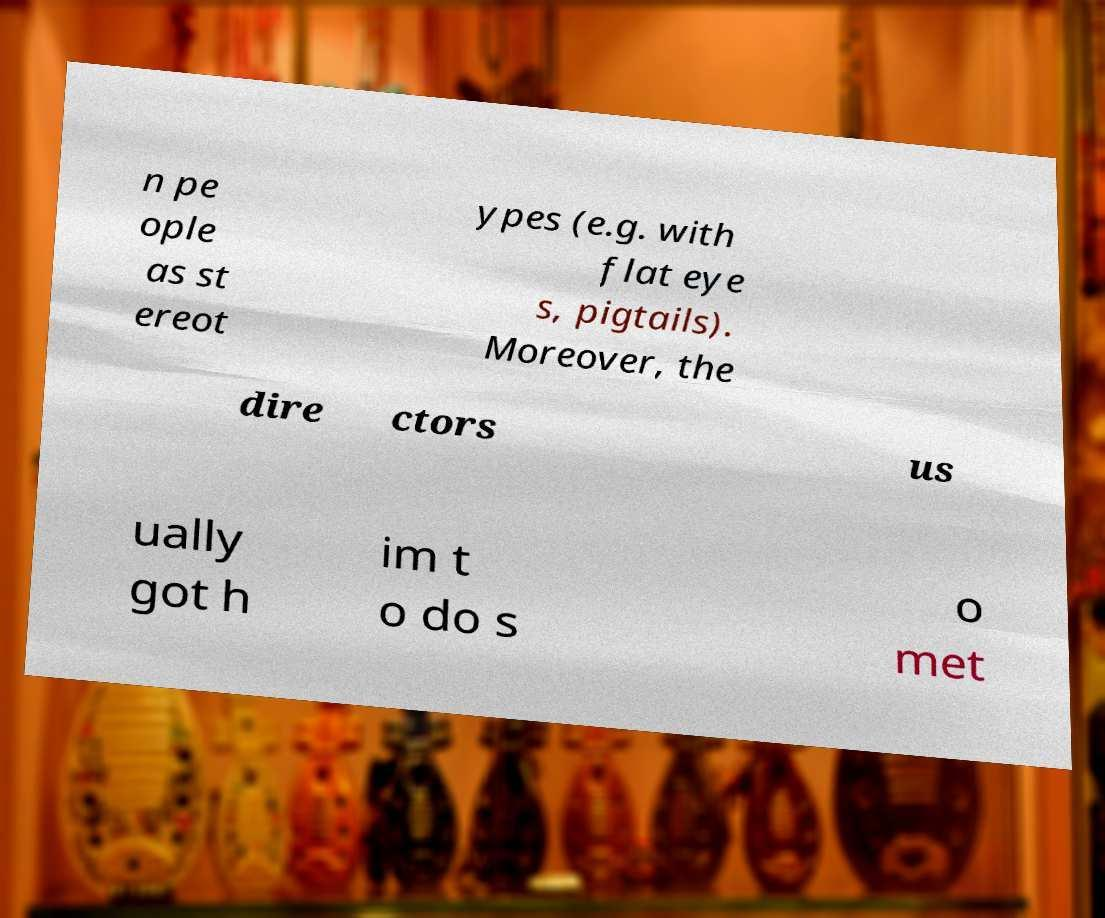What messages or text are displayed in this image? I need them in a readable, typed format. n pe ople as st ereot ypes (e.g. with flat eye s, pigtails). Moreover, the dire ctors us ually got h im t o do s o met 